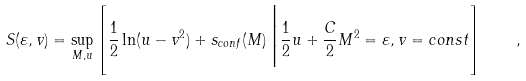<formula> <loc_0><loc_0><loc_500><loc_500>S ( \varepsilon , v ) = \sup _ { M , u } \left [ \frac { 1 } { 2 } \ln ( u - v ^ { 2 } ) + s _ { c o n f } ( M ) \, \Big | \frac { 1 } { 2 } u + \frac { C } { 2 } M ^ { 2 } = \varepsilon , v = c o n s t \right ] \quad ,</formula> 